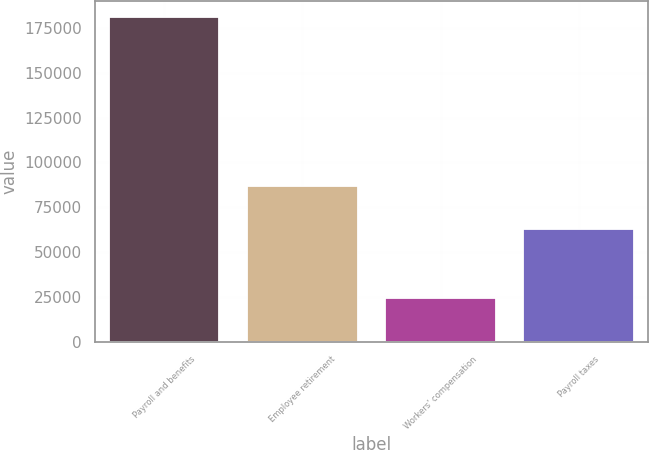Convert chart to OTSL. <chart><loc_0><loc_0><loc_500><loc_500><bar_chart><fcel>Payroll and benefits<fcel>Employee retirement<fcel>Workers' compensation<fcel>Payroll taxes<nl><fcel>181035<fcel>87031<fcel>24217<fcel>63011<nl></chart> 